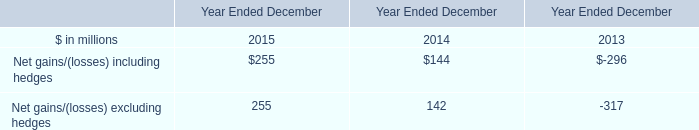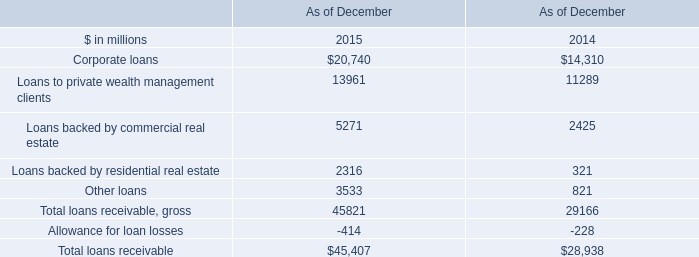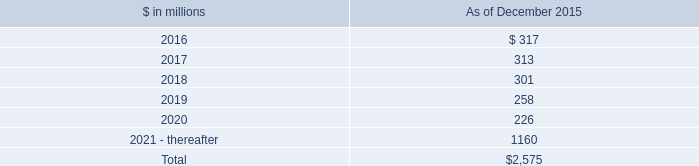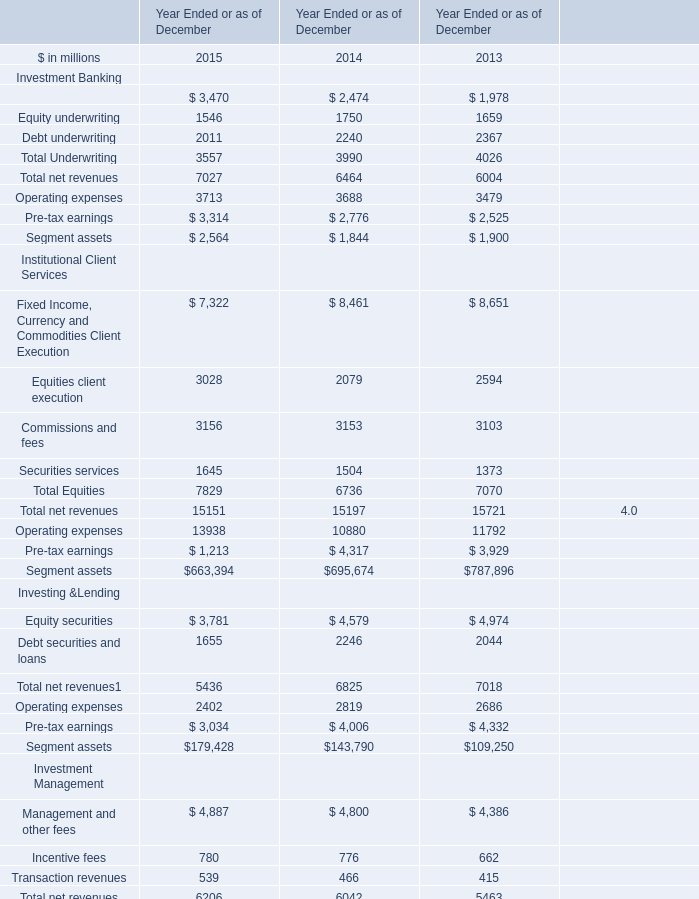What was the average value of Equity securities in the years where Segment assets is positive? (in million) 
Computations: (((3781 + 4579) + 4974) / 3)
Answer: 4444.66667. 